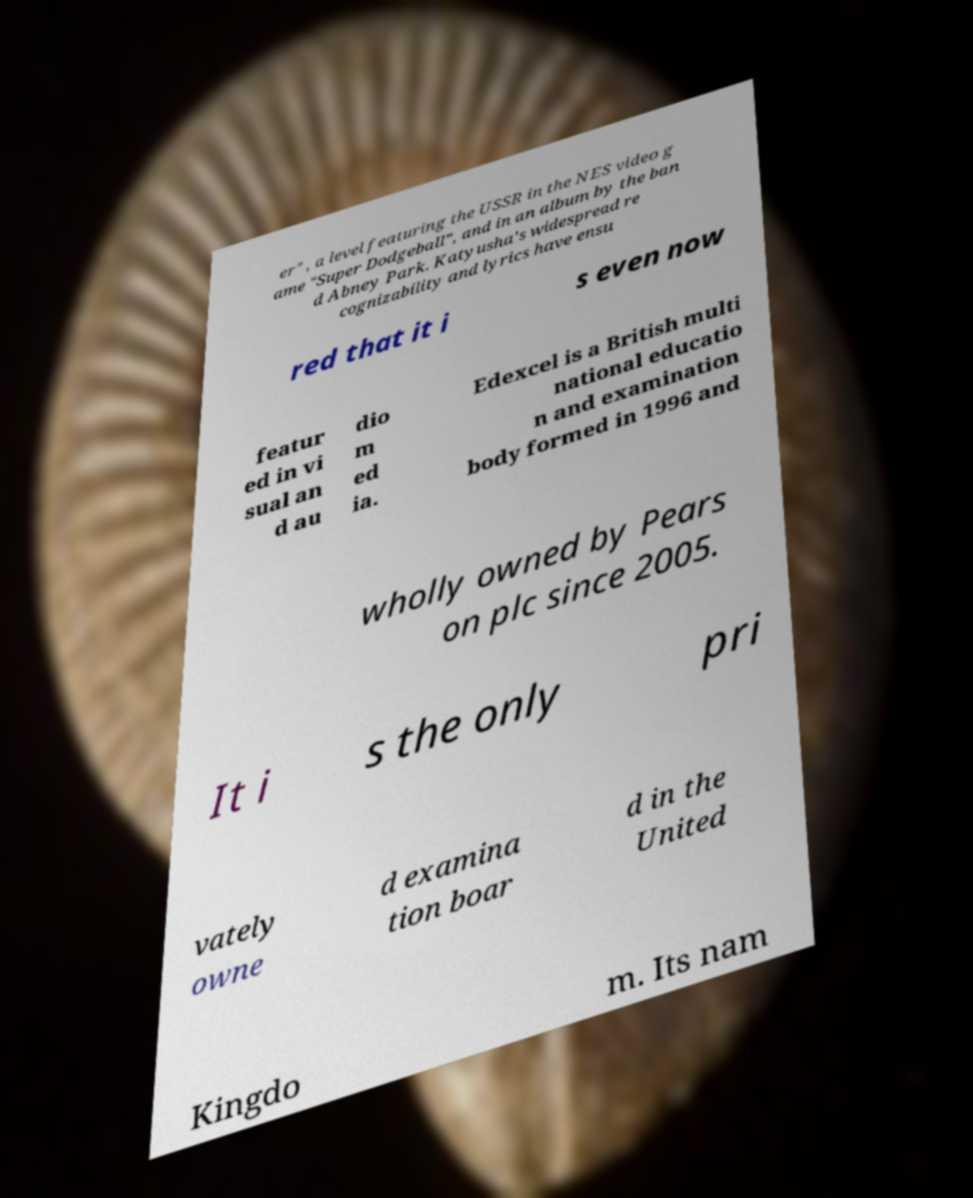I need the written content from this picture converted into text. Can you do that? er" , a level featuring the USSR in the NES video g ame "Super Dodgeball", and in an album by the ban d Abney Park. Katyusha's widespread re cognizability and lyrics have ensu red that it i s even now featur ed in vi sual an d au dio m ed ia. Edexcel is a British multi national educatio n and examination body formed in 1996 and wholly owned by Pears on plc since 2005. It i s the only pri vately owne d examina tion boar d in the United Kingdo m. Its nam 